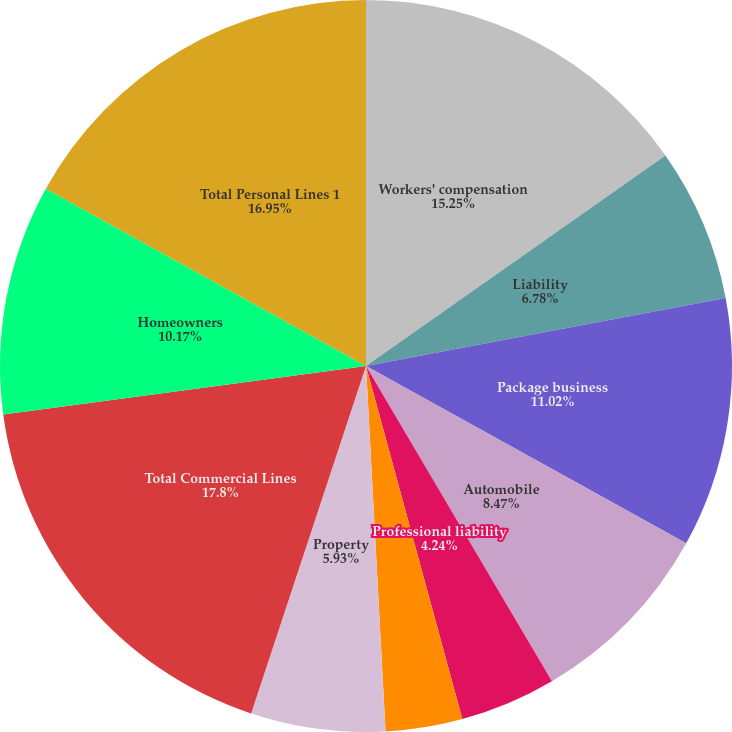Convert chart. <chart><loc_0><loc_0><loc_500><loc_500><pie_chart><fcel>Workers' compensation<fcel>Liability<fcel>Package business<fcel>Automobile<fcel>Professional liability<fcel>Bond<fcel>Property<fcel>Total Commercial Lines<fcel>Homeowners<fcel>Total Personal Lines 1<nl><fcel>15.25%<fcel>6.78%<fcel>11.02%<fcel>8.47%<fcel>4.24%<fcel>3.39%<fcel>5.93%<fcel>17.8%<fcel>10.17%<fcel>16.95%<nl></chart> 